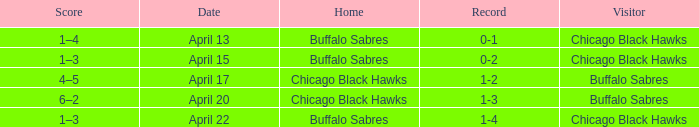Name the Visitor that has a Home of chicago black hawks on april 20? Buffalo Sabres. 